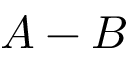<formula> <loc_0><loc_0><loc_500><loc_500>A - B</formula> 